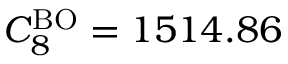<formula> <loc_0><loc_0><loc_500><loc_500>C _ { 8 } ^ { B O } = 1 5 1 4 . 8 6</formula> 